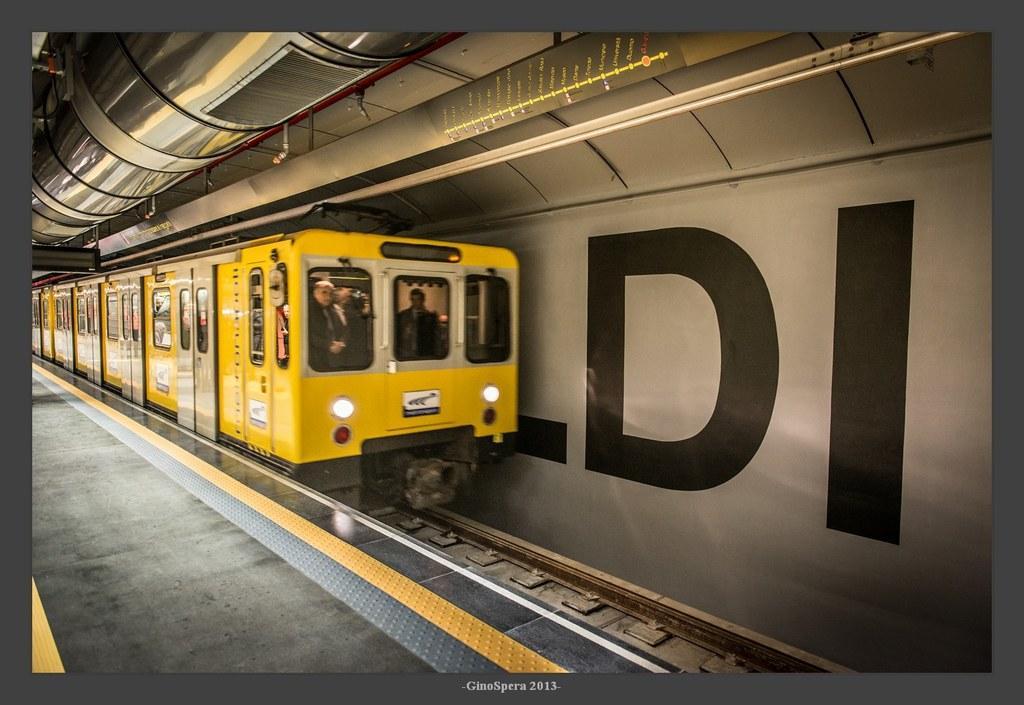Describe this image in one or two sentences. In this image in the center there is one train, at the bottom there is a railway track and floor. In the background there is a wall, on the wall there is some text written. On the top there is ceiling and some sticks. 